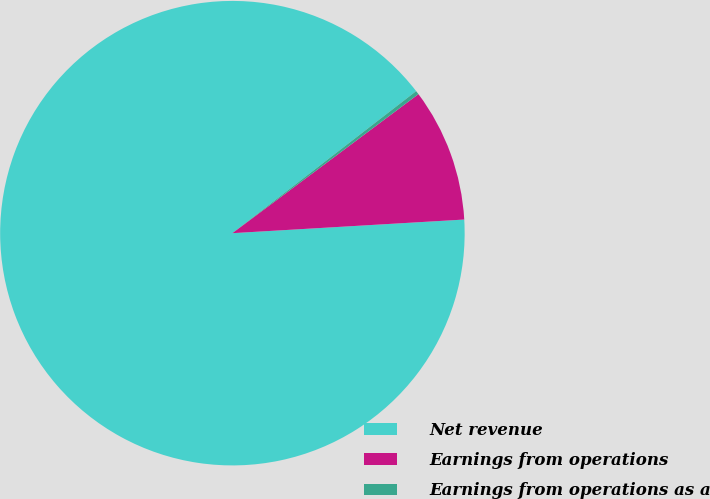Convert chart. <chart><loc_0><loc_0><loc_500><loc_500><pie_chart><fcel>Net revenue<fcel>Earnings from operations<fcel>Earnings from operations as a<nl><fcel>90.47%<fcel>9.28%<fcel>0.26%<nl></chart> 